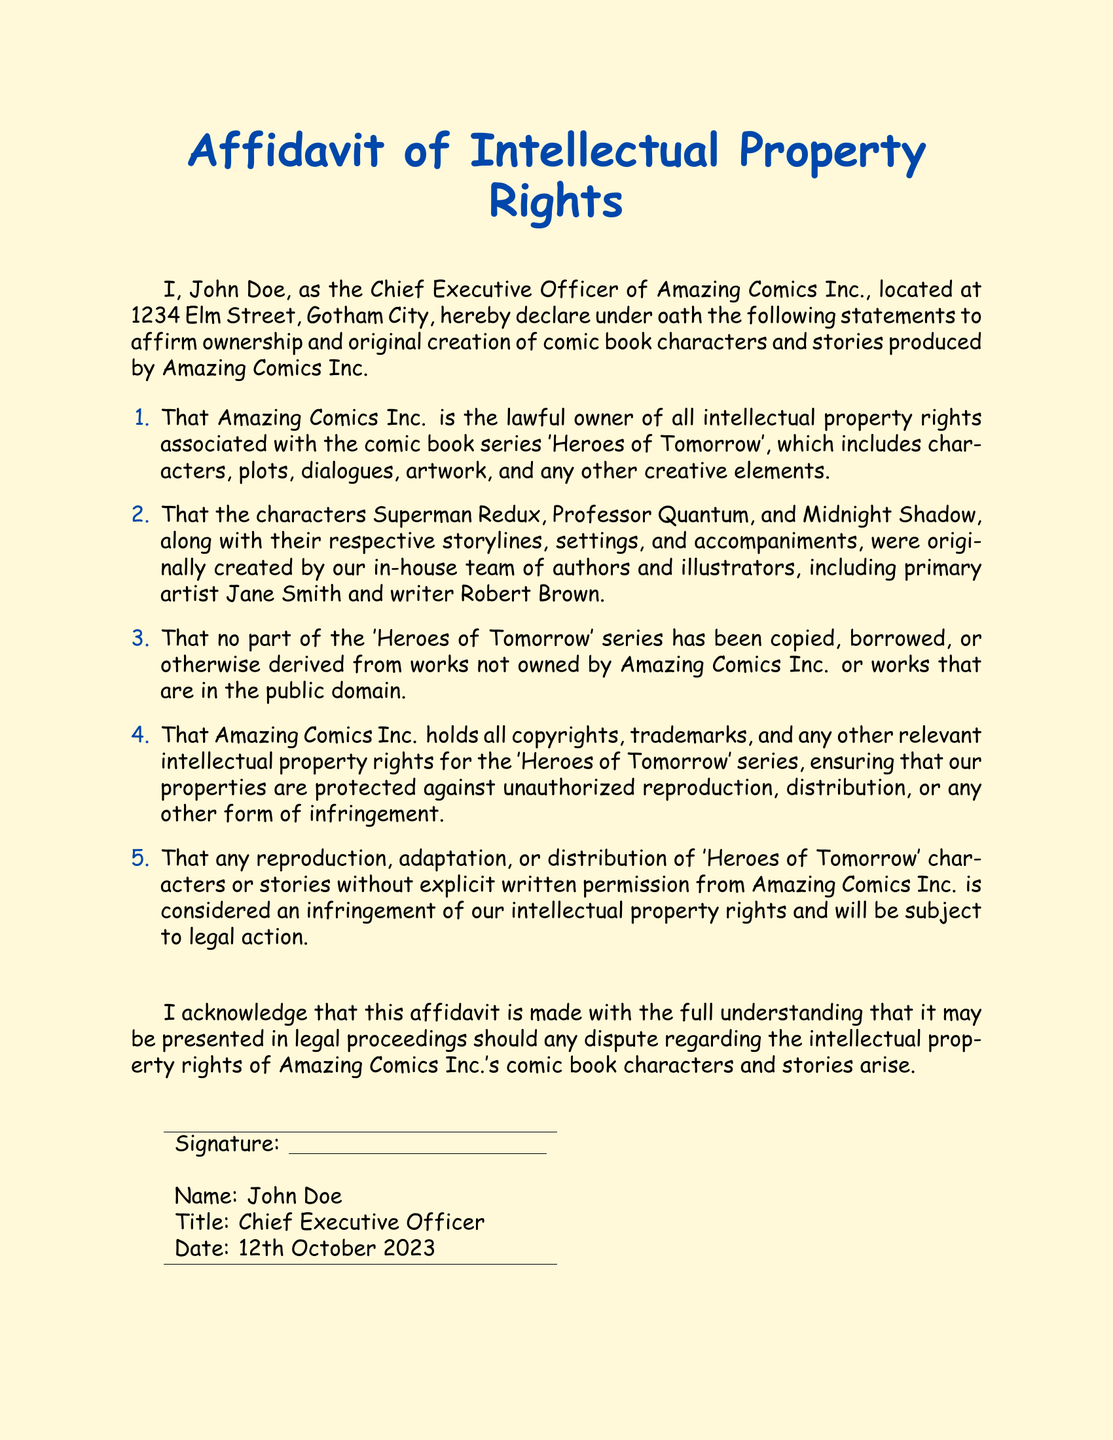What is the title of the affidavit? The title is displayed prominently at the top of the document, indicating the subject of the affidavit.
Answer: Affidavit of Intellectual Property Rights Who is the CEO of Amazing Comics Inc.? The signature section of the document provides the name of the individual in this position.
Answer: John Doe What is the date of the affidavit? The date is mentioned in the signature section, indicating when the affidavit was signed.
Answer: 12th October 2023 Which comic book series is mentioned in the affidavit? The affidavit references a specific comic book series to highlight ownership rights.
Answer: Heroes of Tomorrow What are the names of three characters created by Amazing Comics Inc.? The affidavit lists specific characters to assert intellectual property rights.
Answer: Superman Redux, Professor Quantum, Midnight Shadow What is forbidden without permission according to the affidavit? The affidavit specifies actions that are prohibited regarding the characters or stories.
Answer: Reproduction, adaptation, or distribution What are the protections held by Amazing Comics Inc.? The document outlines the legal protections that Amazing Comics Inc. asserts over its intellectual property.
Answer: Copyrights, trademarks, and any other relevant intellectual property rights What is the purpose of this affidavit? The overall purpose of the affidavit is summarized in the introductory statements.
Answer: To affirm ownership and original creation of comic book characters and stories 